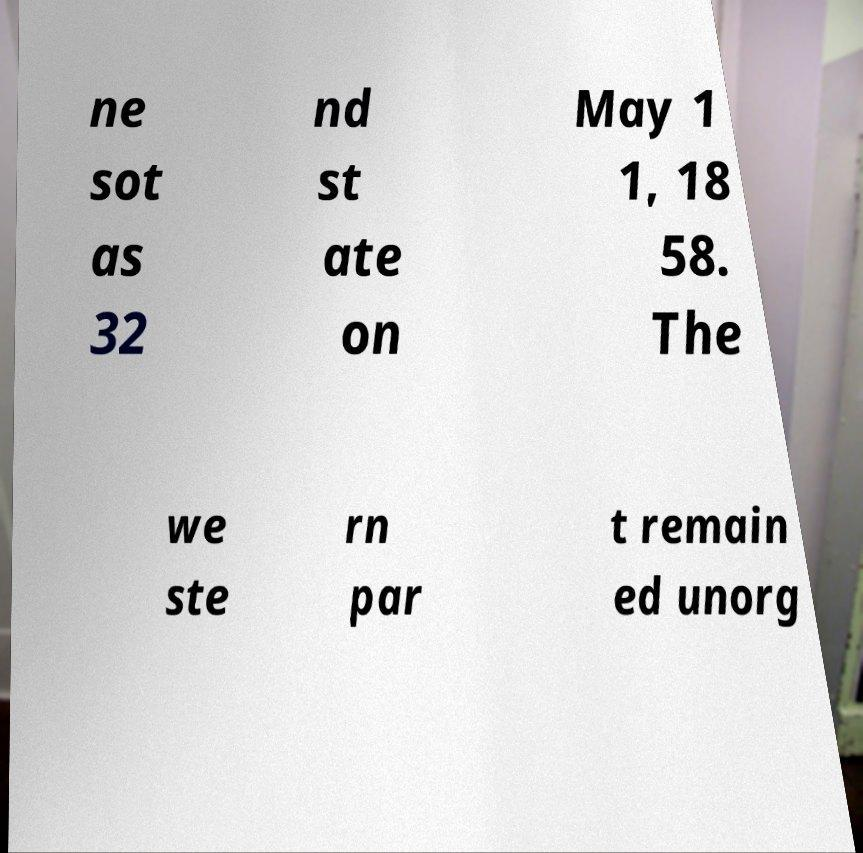Could you extract and type out the text from this image? ne sot as 32 nd st ate on May 1 1, 18 58. The we ste rn par t remain ed unorg 